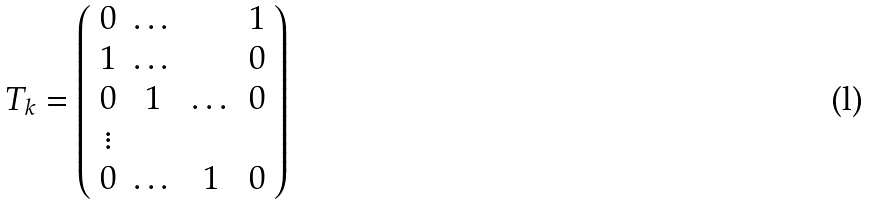Convert formula to latex. <formula><loc_0><loc_0><loc_500><loc_500>T _ { k } = \left ( \begin{array} { c c c c } 0 & \dots & & 1 \\ 1 & \dots & & 0 \\ 0 & 1 & \dots & 0 \\ \vdots & & & \\ 0 & \dots & 1 & 0 \end{array} \right )</formula> 